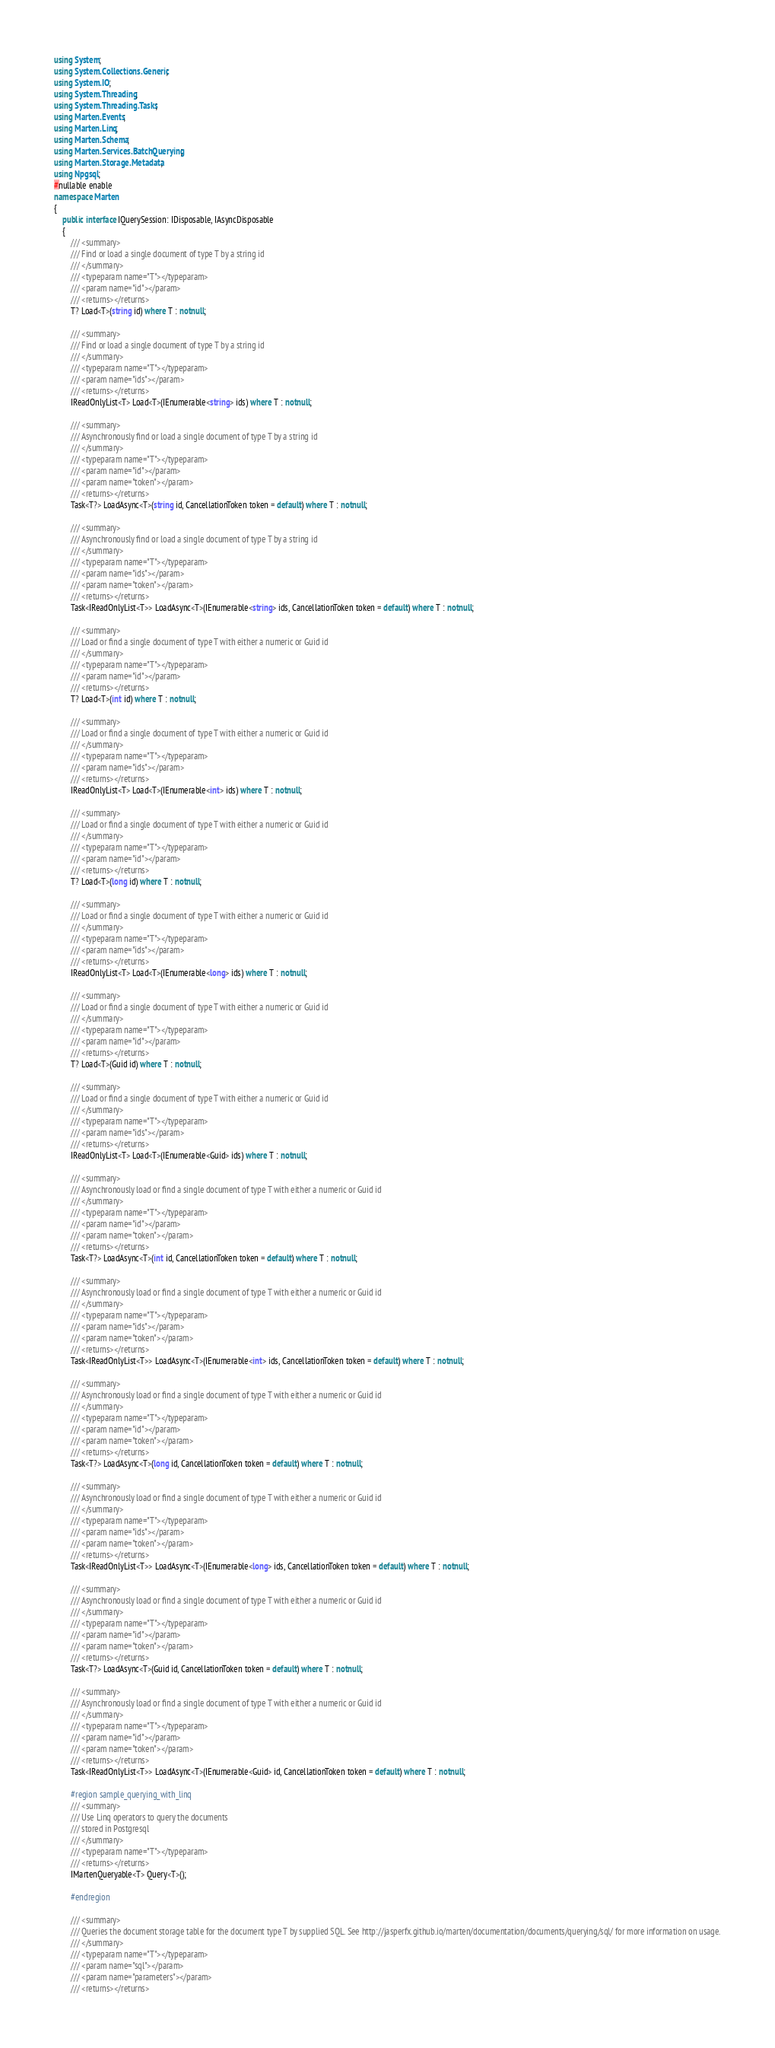Convert code to text. <code><loc_0><loc_0><loc_500><loc_500><_C#_>using System;
using System.Collections.Generic;
using System.IO;
using System.Threading;
using System.Threading.Tasks;
using Marten.Events;
using Marten.Linq;
using Marten.Schema;
using Marten.Services.BatchQuerying;
using Marten.Storage.Metadata;
using Npgsql;
#nullable enable
namespace Marten
{
    public interface IQuerySession: IDisposable, IAsyncDisposable
    {
        /// <summary>
        /// Find or load a single document of type T by a string id
        /// </summary>
        /// <typeparam name="T"></typeparam>
        /// <param name="id"></param>
        /// <returns></returns>
        T? Load<T>(string id) where T : notnull;

        /// <summary>
        /// Find or load a single document of type T by a string id
        /// </summary>
        /// <typeparam name="T"></typeparam>
        /// <param name="ids"></param>
        /// <returns></returns>
        IReadOnlyList<T> Load<T>(IEnumerable<string> ids) where T : notnull;

        /// <summary>
        /// Asynchronously find or load a single document of type T by a string id
        /// </summary>
        /// <typeparam name="T"></typeparam>
        /// <param name="id"></param>
        /// <param name="token"></param>
        /// <returns></returns>
        Task<T?> LoadAsync<T>(string id, CancellationToken token = default) where T : notnull;

        /// <summary>
        /// Asynchronously find or load a single document of type T by a string id
        /// </summary>
        /// <typeparam name="T"></typeparam>
        /// <param name="ids"></param>
        /// <param name="token"></param>
        /// <returns></returns>
        Task<IReadOnlyList<T>> LoadAsync<T>(IEnumerable<string> ids, CancellationToken token = default) where T : notnull;

        /// <summary>
        /// Load or find a single document of type T with either a numeric or Guid id
        /// </summary>
        /// <typeparam name="T"></typeparam>
        /// <param name="id"></param>
        /// <returns></returns>
        T? Load<T>(int id) where T : notnull;

        /// <summary>
        /// Load or find a single document of type T with either a numeric or Guid id
        /// </summary>
        /// <typeparam name="T"></typeparam>
        /// <param name="ids"></param>
        /// <returns></returns>
        IReadOnlyList<T> Load<T>(IEnumerable<int> ids) where T : notnull;

        /// <summary>
        /// Load or find a single document of type T with either a numeric or Guid id
        /// </summary>
        /// <typeparam name="T"></typeparam>
        /// <param name="id"></param>
        /// <returns></returns>
        T? Load<T>(long id) where T : notnull;

        /// <summary>
        /// Load or find a single document of type T with either a numeric or Guid id
        /// </summary>
        /// <typeparam name="T"></typeparam>
        /// <param name="ids"></param>
        /// <returns></returns>
        IReadOnlyList<T> Load<T>(IEnumerable<long> ids) where T : notnull;

        /// <summary>
        /// Load or find a single document of type T with either a numeric or Guid id
        /// </summary>
        /// <typeparam name="T"></typeparam>
        /// <param name="id"></param>
        /// <returns></returns>
        T? Load<T>(Guid id) where T : notnull;

        /// <summary>
        /// Load or find a single document of type T with either a numeric or Guid id
        /// </summary>
        /// <typeparam name="T"></typeparam>
        /// <param name="ids"></param>
        /// <returns></returns>
        IReadOnlyList<T> Load<T>(IEnumerable<Guid> ids) where T : notnull;

        /// <summary>
        /// Asynchronously load or find a single document of type T with either a numeric or Guid id
        /// </summary>
        /// <typeparam name="T"></typeparam>
        /// <param name="id"></param>
        /// <param name="token"></param>
        /// <returns></returns>
        Task<T?> LoadAsync<T>(int id, CancellationToken token = default) where T : notnull;

        /// <summary>
        /// Asynchronously load or find a single document of type T with either a numeric or Guid id
        /// </summary>
        /// <typeparam name="T"></typeparam>
        /// <param name="ids"></param>
        /// <param name="token"></param>
        /// <returns></returns>
        Task<IReadOnlyList<T>> LoadAsync<T>(IEnumerable<int> ids, CancellationToken token = default) where T : notnull;

        /// <summary>
        /// Asynchronously load or find a single document of type T with either a numeric or Guid id
        /// </summary>
        /// <typeparam name="T"></typeparam>
        /// <param name="id"></param>
        /// <param name="token"></param>
        /// <returns></returns>
        Task<T?> LoadAsync<T>(long id, CancellationToken token = default) where T : notnull;

        /// <summary>
        /// Asynchronously load or find a single document of type T with either a numeric or Guid id
        /// </summary>
        /// <typeparam name="T"></typeparam>
        /// <param name="ids"></param>
        /// <param name="token"></param>
        /// <returns></returns>
        Task<IReadOnlyList<T>> LoadAsync<T>(IEnumerable<long> ids, CancellationToken token = default) where T : notnull;

        /// <summary>
        /// Asynchronously load or find a single document of type T with either a numeric or Guid id
        /// </summary>
        /// <typeparam name="T"></typeparam>
        /// <param name="id"></param>
        /// <param name="token"></param>
        /// <returns></returns>
        Task<T?> LoadAsync<T>(Guid id, CancellationToken token = default) where T : notnull;

        /// <summary>
        /// Asynchronously load or find a single document of type T with either a numeric or Guid id
        /// </summary>
        /// <typeparam name="T"></typeparam>
        /// <param name="id"></param>
        /// <param name="token"></param>
        /// <returns></returns>
        Task<IReadOnlyList<T>> LoadAsync<T>(IEnumerable<Guid> id, CancellationToken token = default) where T : notnull;

        #region sample_querying_with_linq
        /// <summary>
        /// Use Linq operators to query the documents
        /// stored in Postgresql
        /// </summary>
        /// <typeparam name="T"></typeparam>
        /// <returns></returns>
        IMartenQueryable<T> Query<T>();

        #endregion

        /// <summary>
        /// Queries the document storage table for the document type T by supplied SQL. See http://jasperfx.github.io/marten/documentation/documents/querying/sql/ for more information on usage.
        /// </summary>
        /// <typeparam name="T"></typeparam>
        /// <param name="sql"></param>
        /// <param name="parameters"></param>
        /// <returns></returns></code> 